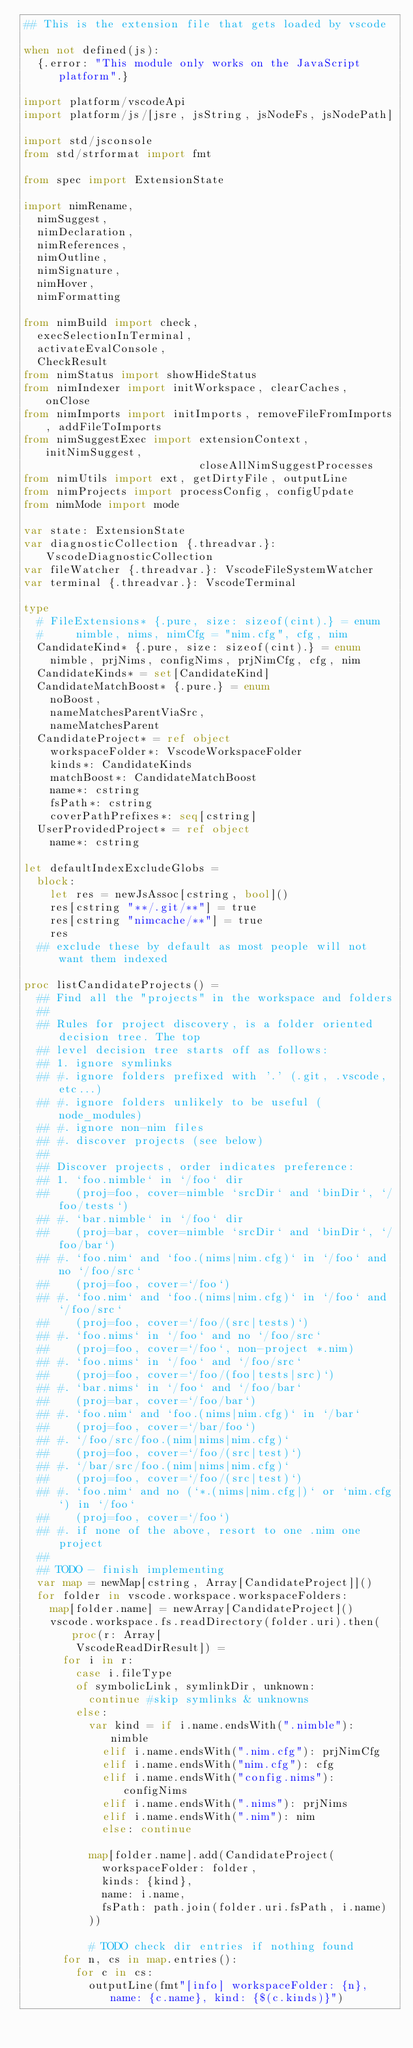Convert code to text. <code><loc_0><loc_0><loc_500><loc_500><_Nim_>## This is the extension file that gets loaded by vscode

when not defined(js):
  {.error: "This module only works on the JavaScript platform".}

import platform/vscodeApi
import platform/js/[jsre, jsString, jsNodeFs, jsNodePath]

import std/jsconsole
from std/strformat import fmt

from spec import ExtensionState

import nimRename,
  nimSuggest,
  nimDeclaration,
  nimReferences,
  nimOutline,
  nimSignature,
  nimHover,
  nimFormatting

from nimBuild import check,
  execSelectionInTerminal,
  activateEvalConsole,
  CheckResult
from nimStatus import showHideStatus
from nimIndexer import initWorkspace, clearCaches, onClose
from nimImports import initImports, removeFileFromImports, addFileToImports
from nimSuggestExec import extensionContext, initNimSuggest,
                           closeAllNimSuggestProcesses
from nimUtils import ext, getDirtyFile, outputLine
from nimProjects import processConfig, configUpdate
from nimMode import mode

var state: ExtensionState
var diagnosticCollection {.threadvar.}: VscodeDiagnosticCollection
var fileWatcher {.threadvar.}: VscodeFileSystemWatcher
var terminal {.threadvar.}: VscodeTerminal

type
  # FileExtensions* {.pure, size: sizeof(cint).} = enum
  #     nimble, nims, nimCfg = "nim.cfg", cfg, nim
  CandidateKind* {.pure, size: sizeof(cint).} = enum
    nimble, prjNims, configNims, prjNimCfg, cfg, nim
  CandidateKinds* = set[CandidateKind]
  CandidateMatchBoost* {.pure.} = enum
    noBoost,
    nameMatchesParentViaSrc,
    nameMatchesParent
  CandidateProject* = ref object
    workspaceFolder*: VscodeWorkspaceFolder
    kinds*: CandidateKinds
    matchBoost*: CandidateMatchBoost
    name*: cstring
    fsPath*: cstring
    coverPathPrefixes*: seq[cstring]
  UserProvidedProject* = ref object
    name*: cstring

let defaultIndexExcludeGlobs =
  block:
    let res = newJsAssoc[cstring, bool]()
    res[cstring "**/.git/**"] = true
    res[cstring "nimcache/**"] = true
    res
  ## exclude these by default as most people will not want them indexed

proc listCandidateProjects() =
  ## Find all the "projects" in the workspace and folders
  ##
  ## Rules for project discovery, is a folder oriented decision tree. The top
  ## level decision tree starts off as follows:
  ## 1. ignore symlinks
  ## #. ignore folders prefixed with '.' (.git, .vscode, etc...)
  ## #. ignore folders unlikely to be useful (node_modules)
  ## #. ignore non-nim files
  ## #. discover projects (see below)
  ##
  ## Discover projects, order indicates preference:
  ## 1. `foo.nimble` in `/foo` dir
  ##    (proj=foo, cover=nimble `srcDir` and `binDir`, `/foo/tests`)
  ## #. `bar.nimble` in `/foo` dir
  ##    (proj=bar, cover=nimble `srcDir` and `binDir`, `/foo/bar`)
  ## #. `foo.nim` and `foo.(nims|nim.cfg)` in `/foo` and no `/foo/src`
  ##    (proj=foo, cover=`/foo`)
  ## #. `foo.nim` and `foo.(nims|nim.cfg)` in `/foo` and `/foo/src`
  ##    (proj=foo, cover=`/foo/(src|tests)`)
  ## #. `foo.nims` in `/foo` and no `/foo/src`
  ##    (proj=foo, cover=`/foo`, non-project *.nim)
  ## #. `foo.nims` in `/foo` and `/foo/src`
  ##    (proj=foo, cover=`/foo/(foo|tests|src)`)
  ## #. `bar.nims` in `/foo` and `/foo/bar`
  ##    (proj=bar, cover=`/foo/bar`)
  ## #. `foo.nim` and `foo.(nims|nim.cfg)` in `/bar`
  ##    (proj=foo, cover=`/bar/foo`)
  ## #. `/foo/src/foo.(nim|nims|nim.cfg)`
  ##    (proj=foo, cover=`/foo/(src|test)`)
  ## #. `/bar/src/foo.(nim|nims|nim.cfg)`
  ##    (proj=foo, cover=`/foo/(src|test)`)
  ## #. `foo.nim` and no (`*.(nims|nim.cfg|)` or `nim.cfg`) in `/foo`
  ##    (proj=foo, cover=`/foo`)
  ## #. if none of the above, resort to one .nim one project
  ##
  ## TODO - finish implementing
  var map = newMap[cstring, Array[CandidateProject]]()
  for folder in vscode.workspace.workspaceFolders:
    map[folder.name] = newArray[CandidateProject]()
    vscode.workspace.fs.readDirectory(folder.uri).then(proc(r: Array[
        VscodeReadDirResult]) =
      for i in r:
        case i.fileType
        of symbolicLink, symlinkDir, unknown:
          continue #skip symlinks & unknowns
        else:
          var kind = if i.name.endsWith(".nimble"): nimble
            elif i.name.endsWith(".nim.cfg"): prjNimCfg
            elif i.name.endsWith("nim.cfg"): cfg
            elif i.name.endsWith("config.nims"): configNims
            elif i.name.endsWith(".nims"): prjNims
            elif i.name.endsWith(".nim"): nim
            else: continue

          map[folder.name].add(CandidateProject(
            workspaceFolder: folder,
            kinds: {kind},
            name: i.name,
            fsPath: path.join(folder.uri.fsPath, i.name)
          ))

          # TODO check dir entries if nothing found
      for n, cs in map.entries():
        for c in cs:
          outputLine(fmt"[info] workspaceFolder: {n}, name: {c.name}, kind: {$(c.kinds)}")</code> 